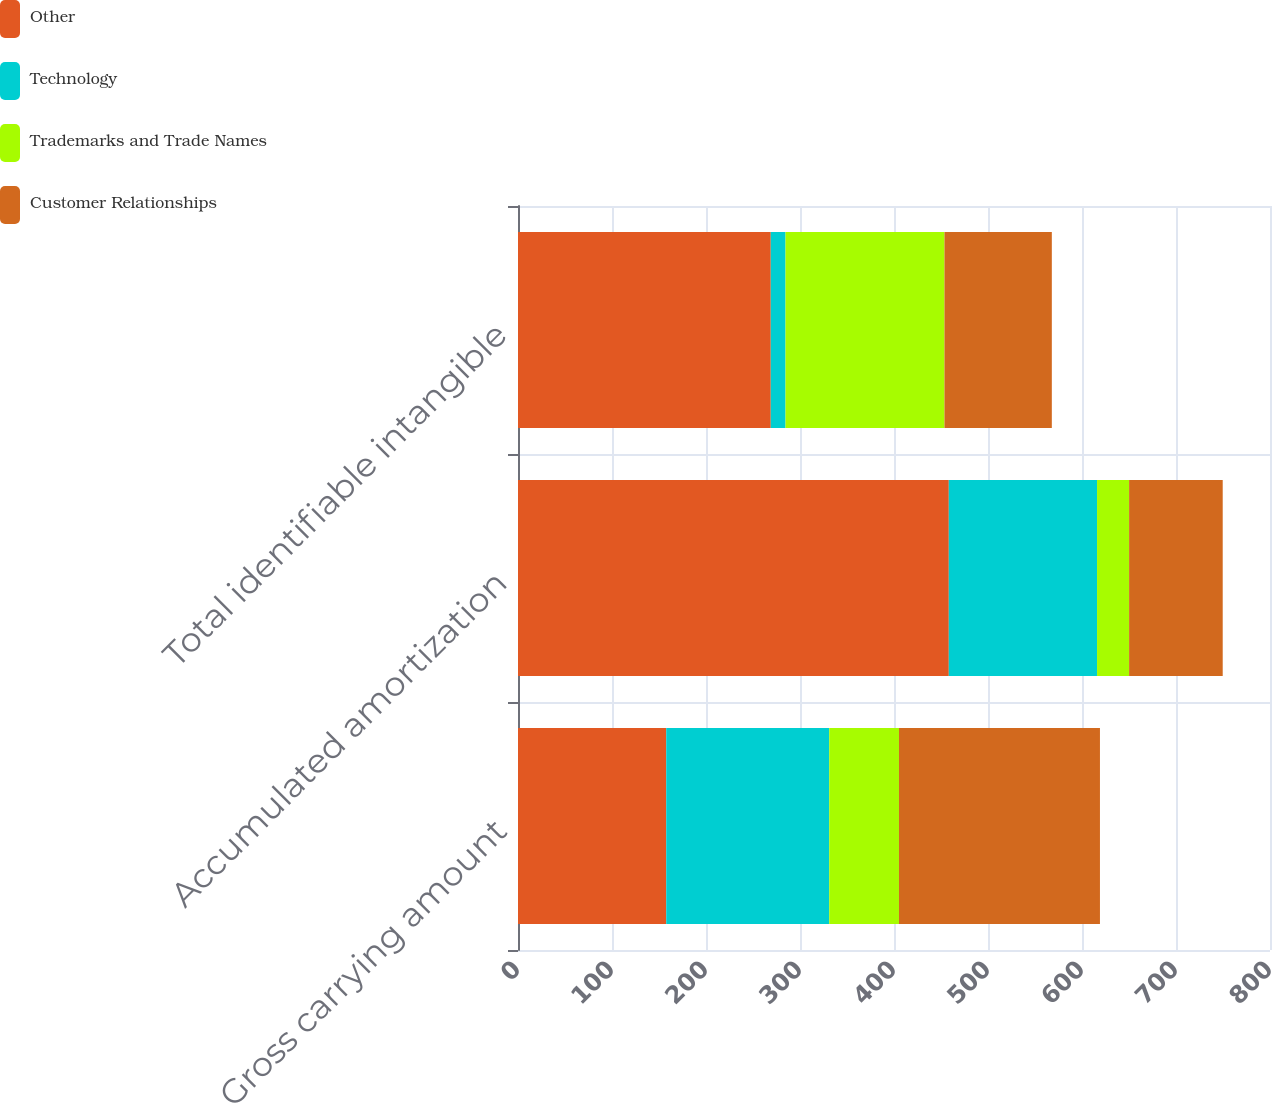Convert chart. <chart><loc_0><loc_0><loc_500><loc_500><stacked_bar_chart><ecel><fcel>Gross carrying amount<fcel>Accumulated amortization<fcel>Total identifiable intangible<nl><fcel>Other<fcel>157.7<fcel>458.3<fcel>268.9<nl><fcel>Technology<fcel>173.4<fcel>157.7<fcel>15.7<nl><fcel>Trademarks and Trade Names<fcel>74.2<fcel>34.1<fcel>169.1<nl><fcel>Customer Relationships<fcel>213.8<fcel>99.6<fcel>114.2<nl></chart> 